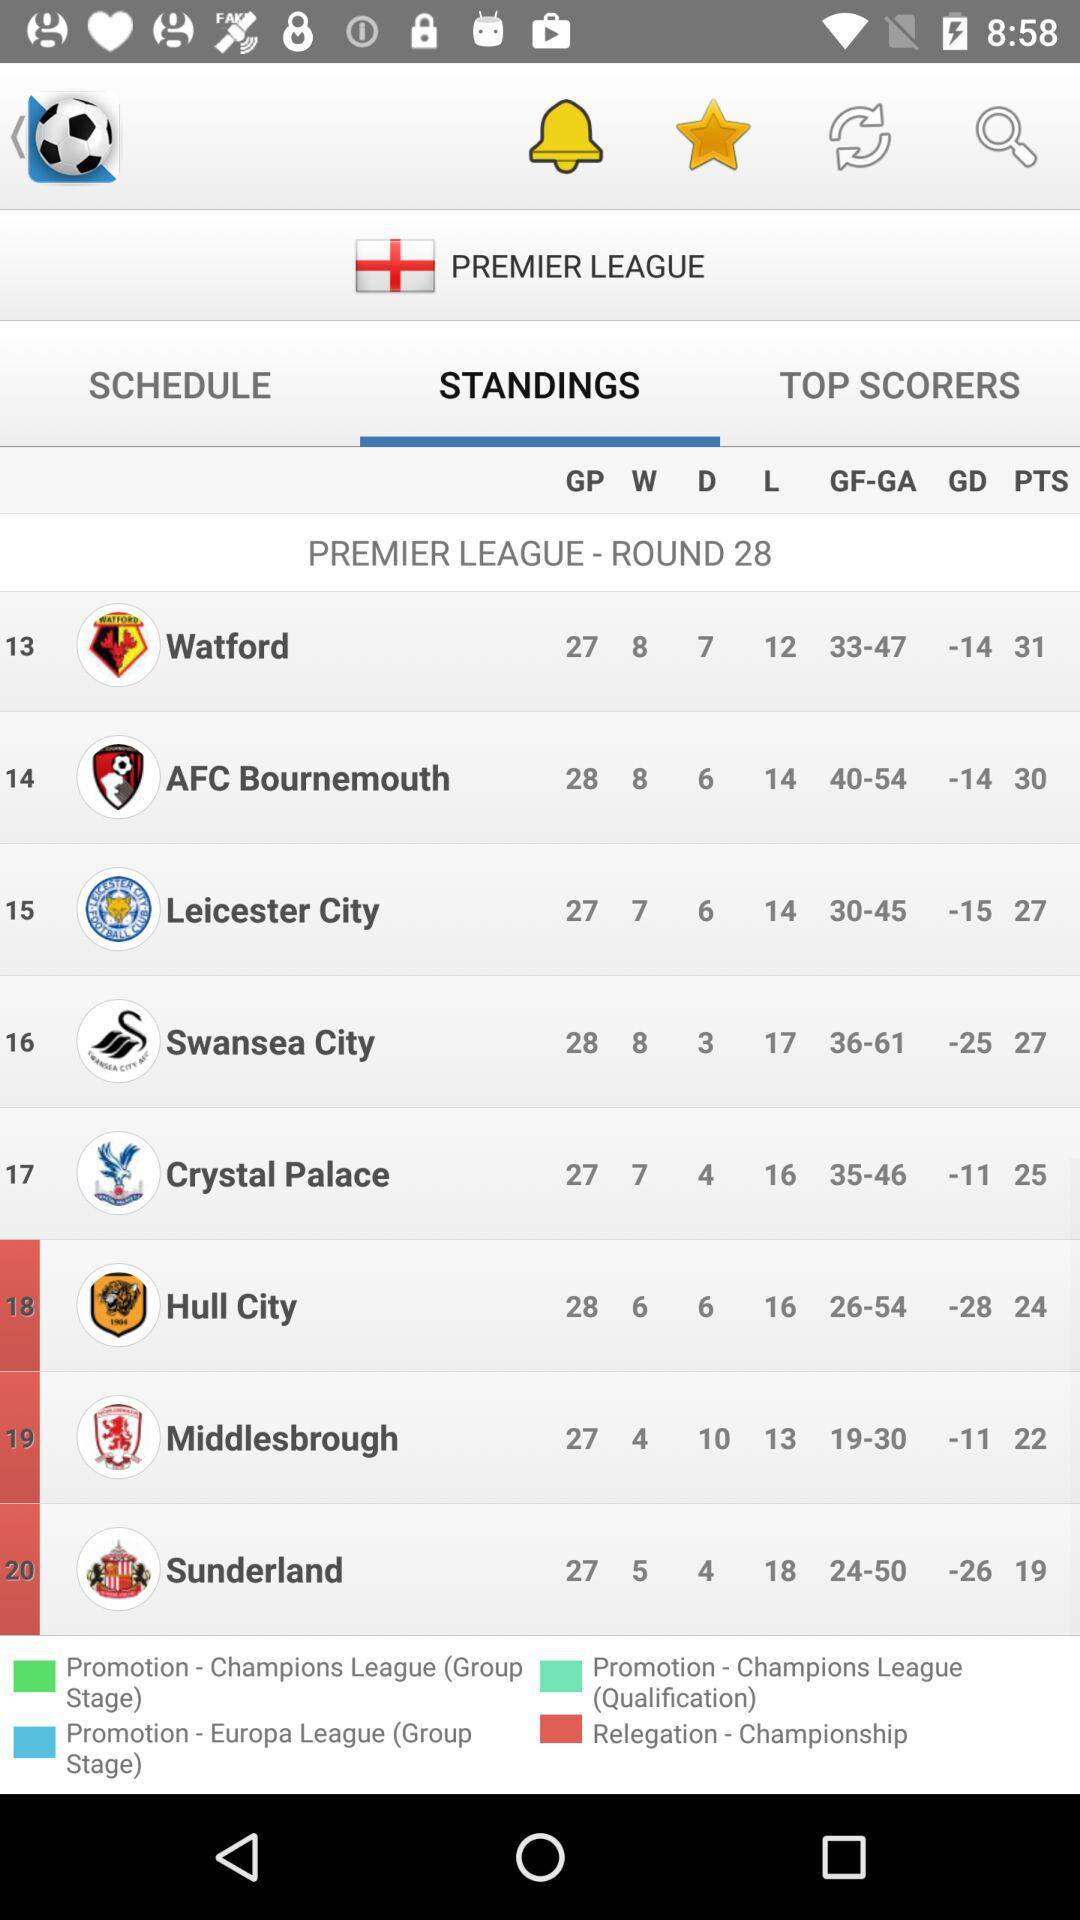What is the round number? The round number is 28. 